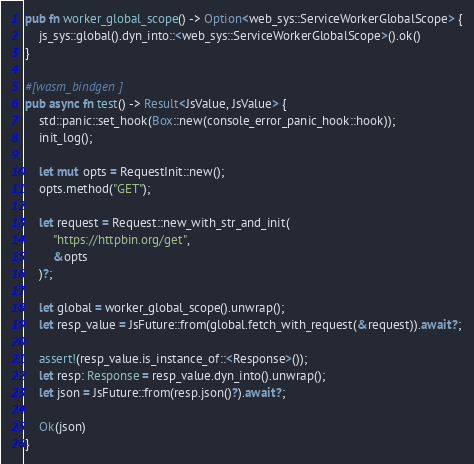<code> <loc_0><loc_0><loc_500><loc_500><_Rust_>
pub fn worker_global_scope() -> Option<web_sys::ServiceWorkerGlobalScope> {
    js_sys::global().dyn_into::<web_sys::ServiceWorkerGlobalScope>().ok()
}

#[wasm_bindgen]
pub async fn test() -> Result<JsValue, JsValue> {
    std::panic::set_hook(Box::new(console_error_panic_hook::hook));
    init_log();

    let mut opts = RequestInit::new();
    opts.method("GET");

    let request = Request::new_with_str_and_init(
        "https://httpbin.org/get",
        &opts
    )?;

    let global = worker_global_scope().unwrap();
    let resp_value = JsFuture::from(global.fetch_with_request(&request)).await?;

    assert!(resp_value.is_instance_of::<Response>());
    let resp: Response = resp_value.dyn_into().unwrap();
    let json = JsFuture::from(resp.json()?).await?;

    Ok(json)
}</code> 